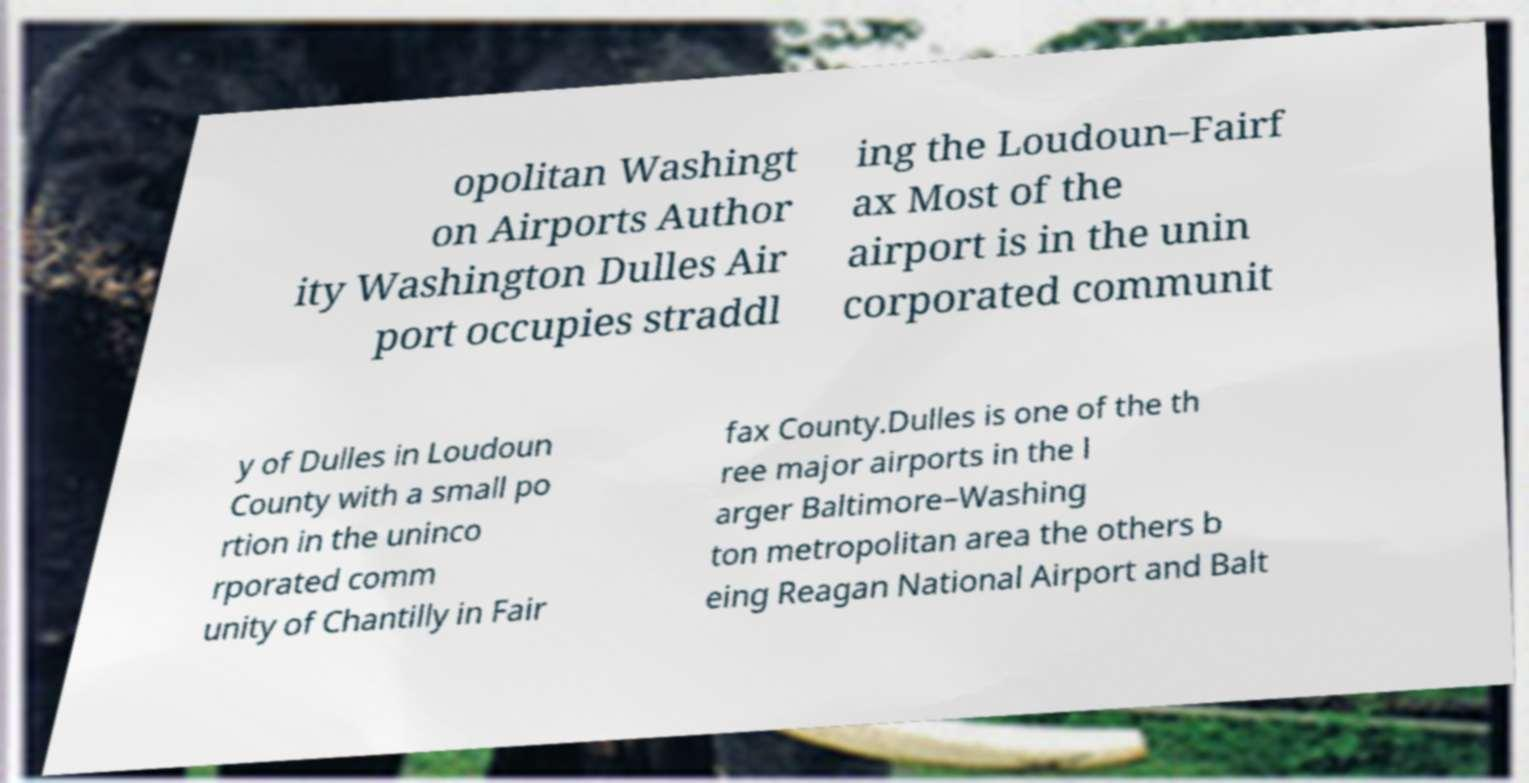Can you read and provide the text displayed in the image?This photo seems to have some interesting text. Can you extract and type it out for me? opolitan Washingt on Airports Author ity Washington Dulles Air port occupies straddl ing the Loudoun–Fairf ax Most of the airport is in the unin corporated communit y of Dulles in Loudoun County with a small po rtion in the uninco rporated comm unity of Chantilly in Fair fax County.Dulles is one of the th ree major airports in the l arger Baltimore–Washing ton metropolitan area the others b eing Reagan National Airport and Balt 